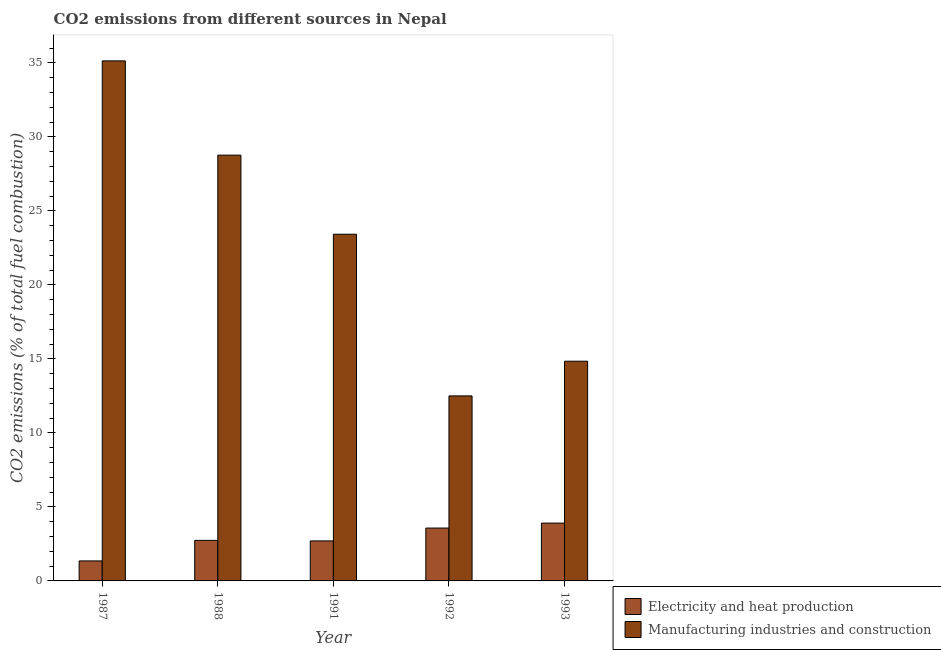How many bars are there on the 5th tick from the left?
Your answer should be very brief. 2. How many bars are there on the 4th tick from the right?
Offer a very short reply. 2. What is the label of the 1st group of bars from the left?
Give a very brief answer. 1987. What is the co2 emissions due to electricity and heat production in 1987?
Ensure brevity in your answer.  1.35. Across all years, what is the maximum co2 emissions due to electricity and heat production?
Your response must be concise. 3.91. Across all years, what is the minimum co2 emissions due to manufacturing industries?
Your answer should be compact. 12.5. In which year was the co2 emissions due to electricity and heat production maximum?
Ensure brevity in your answer.  1993. In which year was the co2 emissions due to electricity and heat production minimum?
Your answer should be compact. 1987. What is the total co2 emissions due to electricity and heat production in the graph?
Your answer should be compact. 14.27. What is the difference between the co2 emissions due to electricity and heat production in 1987 and that in 1992?
Give a very brief answer. -2.22. What is the difference between the co2 emissions due to electricity and heat production in 1992 and the co2 emissions due to manufacturing industries in 1993?
Keep it short and to the point. -0.33. What is the average co2 emissions due to manufacturing industries per year?
Provide a short and direct response. 22.93. In the year 1992, what is the difference between the co2 emissions due to electricity and heat production and co2 emissions due to manufacturing industries?
Make the answer very short. 0. What is the ratio of the co2 emissions due to electricity and heat production in 1991 to that in 1993?
Give a very brief answer. 0.69. Is the co2 emissions due to manufacturing industries in 1987 less than that in 1988?
Give a very brief answer. No. Is the difference between the co2 emissions due to manufacturing industries in 1991 and 1992 greater than the difference between the co2 emissions due to electricity and heat production in 1991 and 1992?
Ensure brevity in your answer.  No. What is the difference between the highest and the second highest co2 emissions due to electricity and heat production?
Make the answer very short. 0.33. What is the difference between the highest and the lowest co2 emissions due to electricity and heat production?
Make the answer very short. 2.55. In how many years, is the co2 emissions due to electricity and heat production greater than the average co2 emissions due to electricity and heat production taken over all years?
Your answer should be very brief. 2. Is the sum of the co2 emissions due to electricity and heat production in 1988 and 1993 greater than the maximum co2 emissions due to manufacturing industries across all years?
Your answer should be compact. Yes. What does the 2nd bar from the left in 1992 represents?
Keep it short and to the point. Manufacturing industries and construction. What does the 2nd bar from the right in 1993 represents?
Your response must be concise. Electricity and heat production. Are all the bars in the graph horizontal?
Provide a succinct answer. No. Does the graph contain any zero values?
Your answer should be compact. No. Where does the legend appear in the graph?
Your answer should be compact. Bottom right. What is the title of the graph?
Give a very brief answer. CO2 emissions from different sources in Nepal. What is the label or title of the Y-axis?
Offer a very short reply. CO2 emissions (% of total fuel combustion). What is the CO2 emissions (% of total fuel combustion) in Electricity and heat production in 1987?
Make the answer very short. 1.35. What is the CO2 emissions (% of total fuel combustion) of Manufacturing industries and construction in 1987?
Provide a succinct answer. 35.14. What is the CO2 emissions (% of total fuel combustion) of Electricity and heat production in 1988?
Provide a short and direct response. 2.74. What is the CO2 emissions (% of total fuel combustion) in Manufacturing industries and construction in 1988?
Give a very brief answer. 28.77. What is the CO2 emissions (% of total fuel combustion) of Electricity and heat production in 1991?
Provide a short and direct response. 2.7. What is the CO2 emissions (% of total fuel combustion) of Manufacturing industries and construction in 1991?
Ensure brevity in your answer.  23.42. What is the CO2 emissions (% of total fuel combustion) of Electricity and heat production in 1992?
Offer a very short reply. 3.57. What is the CO2 emissions (% of total fuel combustion) of Electricity and heat production in 1993?
Your response must be concise. 3.91. What is the CO2 emissions (% of total fuel combustion) of Manufacturing industries and construction in 1993?
Offer a terse response. 14.84. Across all years, what is the maximum CO2 emissions (% of total fuel combustion) in Electricity and heat production?
Provide a succinct answer. 3.91. Across all years, what is the maximum CO2 emissions (% of total fuel combustion) of Manufacturing industries and construction?
Keep it short and to the point. 35.14. Across all years, what is the minimum CO2 emissions (% of total fuel combustion) of Electricity and heat production?
Give a very brief answer. 1.35. Across all years, what is the minimum CO2 emissions (% of total fuel combustion) of Manufacturing industries and construction?
Offer a very short reply. 12.5. What is the total CO2 emissions (% of total fuel combustion) in Electricity and heat production in the graph?
Your answer should be very brief. 14.27. What is the total CO2 emissions (% of total fuel combustion) of Manufacturing industries and construction in the graph?
Ensure brevity in your answer.  114.67. What is the difference between the CO2 emissions (% of total fuel combustion) in Electricity and heat production in 1987 and that in 1988?
Provide a short and direct response. -1.39. What is the difference between the CO2 emissions (% of total fuel combustion) of Manufacturing industries and construction in 1987 and that in 1988?
Your response must be concise. 6.37. What is the difference between the CO2 emissions (% of total fuel combustion) of Electricity and heat production in 1987 and that in 1991?
Provide a succinct answer. -1.35. What is the difference between the CO2 emissions (% of total fuel combustion) in Manufacturing industries and construction in 1987 and that in 1991?
Offer a very short reply. 11.71. What is the difference between the CO2 emissions (% of total fuel combustion) in Electricity and heat production in 1987 and that in 1992?
Give a very brief answer. -2.22. What is the difference between the CO2 emissions (% of total fuel combustion) of Manufacturing industries and construction in 1987 and that in 1992?
Offer a very short reply. 22.64. What is the difference between the CO2 emissions (% of total fuel combustion) of Electricity and heat production in 1987 and that in 1993?
Keep it short and to the point. -2.55. What is the difference between the CO2 emissions (% of total fuel combustion) of Manufacturing industries and construction in 1987 and that in 1993?
Ensure brevity in your answer.  20.29. What is the difference between the CO2 emissions (% of total fuel combustion) of Electricity and heat production in 1988 and that in 1991?
Offer a very short reply. 0.04. What is the difference between the CO2 emissions (% of total fuel combustion) of Manufacturing industries and construction in 1988 and that in 1991?
Provide a short and direct response. 5.34. What is the difference between the CO2 emissions (% of total fuel combustion) in Electricity and heat production in 1988 and that in 1992?
Give a very brief answer. -0.83. What is the difference between the CO2 emissions (% of total fuel combustion) of Manufacturing industries and construction in 1988 and that in 1992?
Make the answer very short. 16.27. What is the difference between the CO2 emissions (% of total fuel combustion) of Electricity and heat production in 1988 and that in 1993?
Your response must be concise. -1.17. What is the difference between the CO2 emissions (% of total fuel combustion) in Manufacturing industries and construction in 1988 and that in 1993?
Keep it short and to the point. 13.92. What is the difference between the CO2 emissions (% of total fuel combustion) of Electricity and heat production in 1991 and that in 1992?
Keep it short and to the point. -0.87. What is the difference between the CO2 emissions (% of total fuel combustion) of Manufacturing industries and construction in 1991 and that in 1992?
Keep it short and to the point. 10.92. What is the difference between the CO2 emissions (% of total fuel combustion) of Electricity and heat production in 1991 and that in 1993?
Provide a short and direct response. -1.2. What is the difference between the CO2 emissions (% of total fuel combustion) of Manufacturing industries and construction in 1991 and that in 1993?
Your answer should be compact. 8.58. What is the difference between the CO2 emissions (% of total fuel combustion) of Electricity and heat production in 1992 and that in 1993?
Offer a very short reply. -0.33. What is the difference between the CO2 emissions (% of total fuel combustion) of Manufacturing industries and construction in 1992 and that in 1993?
Your answer should be compact. -2.34. What is the difference between the CO2 emissions (% of total fuel combustion) in Electricity and heat production in 1987 and the CO2 emissions (% of total fuel combustion) in Manufacturing industries and construction in 1988?
Your answer should be compact. -27.42. What is the difference between the CO2 emissions (% of total fuel combustion) of Electricity and heat production in 1987 and the CO2 emissions (% of total fuel combustion) of Manufacturing industries and construction in 1991?
Keep it short and to the point. -22.07. What is the difference between the CO2 emissions (% of total fuel combustion) in Electricity and heat production in 1987 and the CO2 emissions (% of total fuel combustion) in Manufacturing industries and construction in 1992?
Provide a short and direct response. -11.15. What is the difference between the CO2 emissions (% of total fuel combustion) of Electricity and heat production in 1987 and the CO2 emissions (% of total fuel combustion) of Manufacturing industries and construction in 1993?
Keep it short and to the point. -13.49. What is the difference between the CO2 emissions (% of total fuel combustion) of Electricity and heat production in 1988 and the CO2 emissions (% of total fuel combustion) of Manufacturing industries and construction in 1991?
Your answer should be very brief. -20.68. What is the difference between the CO2 emissions (% of total fuel combustion) of Electricity and heat production in 1988 and the CO2 emissions (% of total fuel combustion) of Manufacturing industries and construction in 1992?
Make the answer very short. -9.76. What is the difference between the CO2 emissions (% of total fuel combustion) of Electricity and heat production in 1988 and the CO2 emissions (% of total fuel combustion) of Manufacturing industries and construction in 1993?
Ensure brevity in your answer.  -12.1. What is the difference between the CO2 emissions (% of total fuel combustion) of Electricity and heat production in 1991 and the CO2 emissions (% of total fuel combustion) of Manufacturing industries and construction in 1992?
Your response must be concise. -9.8. What is the difference between the CO2 emissions (% of total fuel combustion) of Electricity and heat production in 1991 and the CO2 emissions (% of total fuel combustion) of Manufacturing industries and construction in 1993?
Ensure brevity in your answer.  -12.14. What is the difference between the CO2 emissions (% of total fuel combustion) of Electricity and heat production in 1992 and the CO2 emissions (% of total fuel combustion) of Manufacturing industries and construction in 1993?
Give a very brief answer. -11.27. What is the average CO2 emissions (% of total fuel combustion) in Electricity and heat production per year?
Your answer should be compact. 2.85. What is the average CO2 emissions (% of total fuel combustion) of Manufacturing industries and construction per year?
Offer a very short reply. 22.93. In the year 1987, what is the difference between the CO2 emissions (% of total fuel combustion) in Electricity and heat production and CO2 emissions (% of total fuel combustion) in Manufacturing industries and construction?
Provide a succinct answer. -33.78. In the year 1988, what is the difference between the CO2 emissions (% of total fuel combustion) of Electricity and heat production and CO2 emissions (% of total fuel combustion) of Manufacturing industries and construction?
Keep it short and to the point. -26.03. In the year 1991, what is the difference between the CO2 emissions (% of total fuel combustion) of Electricity and heat production and CO2 emissions (% of total fuel combustion) of Manufacturing industries and construction?
Offer a terse response. -20.72. In the year 1992, what is the difference between the CO2 emissions (% of total fuel combustion) of Electricity and heat production and CO2 emissions (% of total fuel combustion) of Manufacturing industries and construction?
Keep it short and to the point. -8.93. In the year 1993, what is the difference between the CO2 emissions (% of total fuel combustion) of Electricity and heat production and CO2 emissions (% of total fuel combustion) of Manufacturing industries and construction?
Provide a short and direct response. -10.94. What is the ratio of the CO2 emissions (% of total fuel combustion) of Electricity and heat production in 1987 to that in 1988?
Offer a very short reply. 0.49. What is the ratio of the CO2 emissions (% of total fuel combustion) of Manufacturing industries and construction in 1987 to that in 1988?
Provide a succinct answer. 1.22. What is the ratio of the CO2 emissions (% of total fuel combustion) of Electricity and heat production in 1987 to that in 1991?
Your answer should be compact. 0.5. What is the ratio of the CO2 emissions (% of total fuel combustion) of Manufacturing industries and construction in 1987 to that in 1991?
Your answer should be compact. 1.5. What is the ratio of the CO2 emissions (% of total fuel combustion) of Electricity and heat production in 1987 to that in 1992?
Your response must be concise. 0.38. What is the ratio of the CO2 emissions (% of total fuel combustion) of Manufacturing industries and construction in 1987 to that in 1992?
Ensure brevity in your answer.  2.81. What is the ratio of the CO2 emissions (% of total fuel combustion) in Electricity and heat production in 1987 to that in 1993?
Provide a short and direct response. 0.35. What is the ratio of the CO2 emissions (% of total fuel combustion) in Manufacturing industries and construction in 1987 to that in 1993?
Provide a succinct answer. 2.37. What is the ratio of the CO2 emissions (% of total fuel combustion) in Electricity and heat production in 1988 to that in 1991?
Your answer should be very brief. 1.01. What is the ratio of the CO2 emissions (% of total fuel combustion) in Manufacturing industries and construction in 1988 to that in 1991?
Your response must be concise. 1.23. What is the ratio of the CO2 emissions (% of total fuel combustion) of Electricity and heat production in 1988 to that in 1992?
Provide a succinct answer. 0.77. What is the ratio of the CO2 emissions (% of total fuel combustion) of Manufacturing industries and construction in 1988 to that in 1992?
Provide a succinct answer. 2.3. What is the ratio of the CO2 emissions (% of total fuel combustion) of Electricity and heat production in 1988 to that in 1993?
Your response must be concise. 0.7. What is the ratio of the CO2 emissions (% of total fuel combustion) of Manufacturing industries and construction in 1988 to that in 1993?
Give a very brief answer. 1.94. What is the ratio of the CO2 emissions (% of total fuel combustion) in Electricity and heat production in 1991 to that in 1992?
Offer a terse response. 0.76. What is the ratio of the CO2 emissions (% of total fuel combustion) in Manufacturing industries and construction in 1991 to that in 1992?
Give a very brief answer. 1.87. What is the ratio of the CO2 emissions (% of total fuel combustion) in Electricity and heat production in 1991 to that in 1993?
Offer a terse response. 0.69. What is the ratio of the CO2 emissions (% of total fuel combustion) in Manufacturing industries and construction in 1991 to that in 1993?
Offer a very short reply. 1.58. What is the ratio of the CO2 emissions (% of total fuel combustion) of Electricity and heat production in 1992 to that in 1993?
Keep it short and to the point. 0.91. What is the ratio of the CO2 emissions (% of total fuel combustion) of Manufacturing industries and construction in 1992 to that in 1993?
Offer a very short reply. 0.84. What is the difference between the highest and the second highest CO2 emissions (% of total fuel combustion) of Electricity and heat production?
Provide a succinct answer. 0.33. What is the difference between the highest and the second highest CO2 emissions (% of total fuel combustion) of Manufacturing industries and construction?
Your answer should be very brief. 6.37. What is the difference between the highest and the lowest CO2 emissions (% of total fuel combustion) of Electricity and heat production?
Offer a very short reply. 2.55. What is the difference between the highest and the lowest CO2 emissions (% of total fuel combustion) of Manufacturing industries and construction?
Keep it short and to the point. 22.64. 